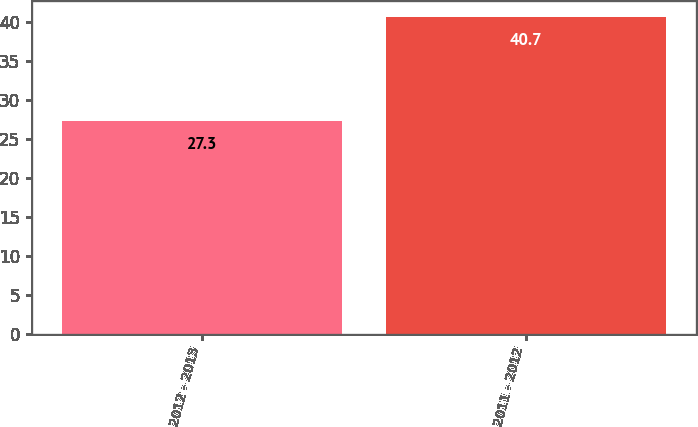Convert chart. <chart><loc_0><loc_0><loc_500><loc_500><bar_chart><fcel>2012 - 2013<fcel>2011 - 2012<nl><fcel>27.3<fcel>40.7<nl></chart> 